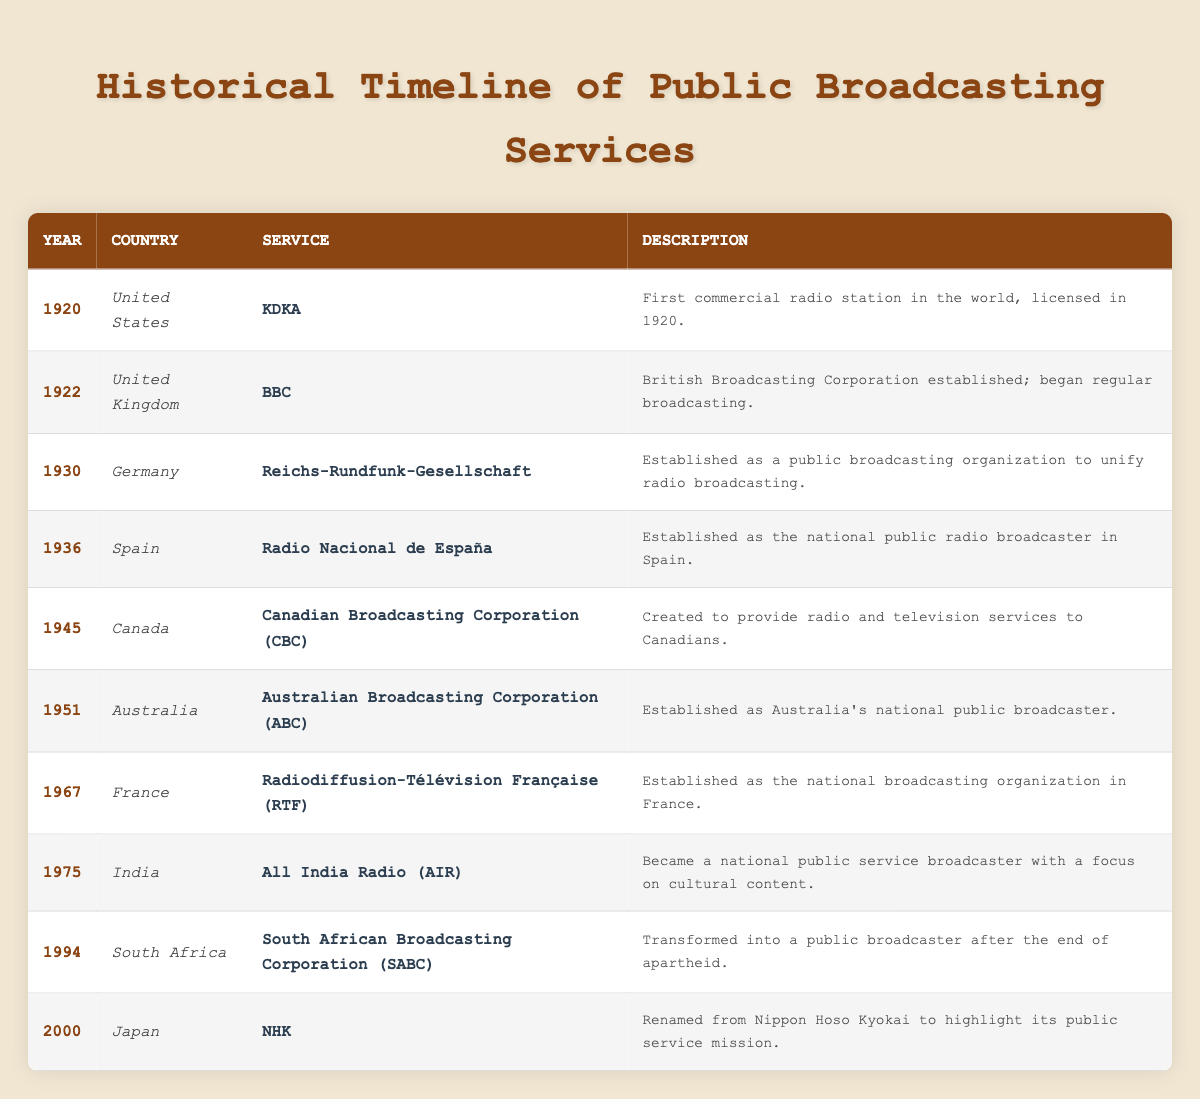What was the first public broadcasting service established in the table? KDKA is listed in the table as the first public broadcasting service established in 1920 in the United States.
Answer: KDKA Which country established the BBC and in what year? The table indicates that the BBC was established in 1922 in the United Kingdom.
Answer: United Kingdom, 1922 How many years are there between the establishment of KDKA and the Australian Broadcasting Corporation (ABC)? KDKA was established in 1920 and ABC in 1951. The difference is 1951 - 1920 = 31 years.
Answer: 31 years Is the South African Broadcasting Corporation (SABC) the first public broadcaster in Africa according to the table? The table shows that SABC was transformed into a public broadcaster in 1994, but it does not provide information about any earlier African public broadcasters, so we cannot definitively say yes or no.
Answer: No Which service was established most recently, and what was its year of establishment? According to the table, the NHK service in Japan was established in 2000. This is the latest date listed.
Answer: NHK, 2000 How many services were established before 1940? By examining the years listed, KDKA (1920), BBC (1922), Reichs-Rundfunk-Gesellschaft (1930), and Radio Nacional de España (1936) were all established before 1940, totaling four services.
Answer: 4 services Which country established its public broadcaster in 1967, and what is the name of the service? The table indicates that France established the Radiodiffusion-Télévision Française in 1967.
Answer: France, Radiodiffusion-Télévision Française Was All India Radio established before or after the creation of the Canadian Broadcasting Corporation? The table shows that AIR was established in 1975 while CBC was established in 1945, meaning AIR was established after.
Answer: After 